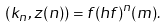<formula> <loc_0><loc_0><loc_500><loc_500>( k _ { n } , z ( n ) ) = f ( h f ) ^ { n } ( m ) .</formula> 